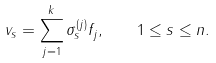Convert formula to latex. <formula><loc_0><loc_0><loc_500><loc_500>v _ { s } = \sum _ { j = 1 } ^ { k } \sigma _ { s } ^ { ( j ) } f _ { j } , \quad 1 \leq s \leq n .</formula> 